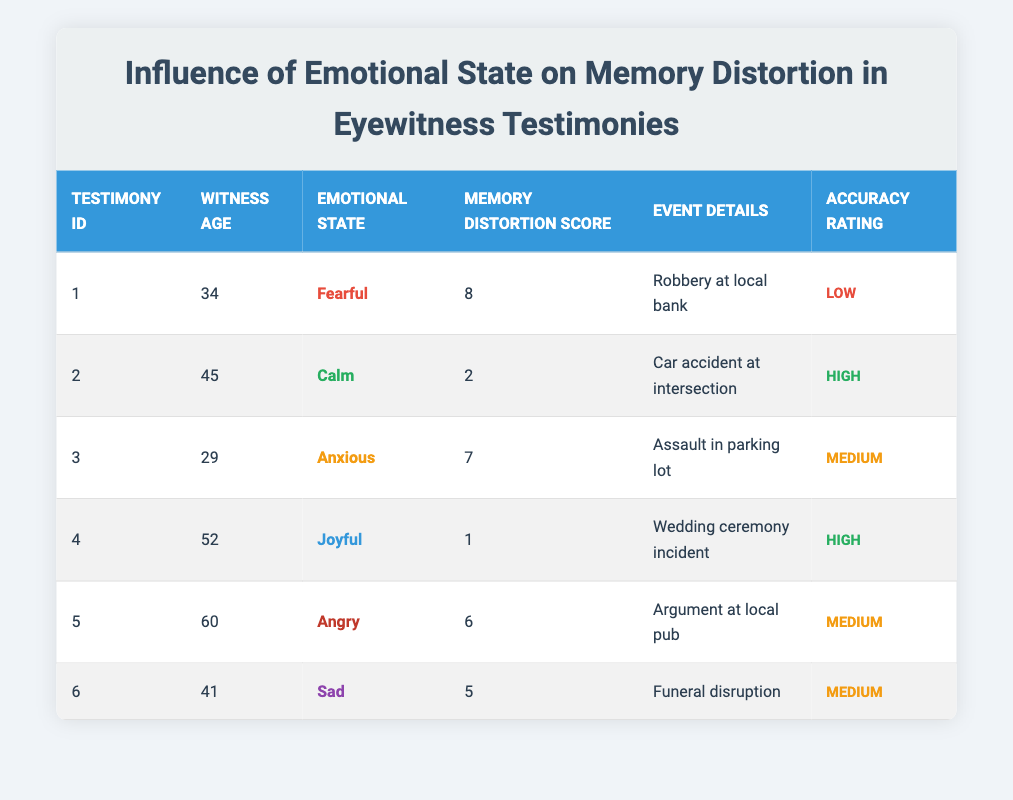What is the Memory Distortion Score for the witness aged 34? From the table, the witness aged 34 is connected to Testimony ID 1, which has a Memory Distortion Score of 8.
Answer: 8 What Emotional State corresponds with the highest Memory Distortion Score? The highest Memory Distortion Score is 8 for the witness with Testimony ID 1, whose Emotional State is "Fearful."
Answer: Fearful How many eyewitness testimonies received a "High" Accuracy Rating? The table shows two testimonies with a "High" Accuracy Rating: Testimony ID 2 (Calm) and Testimony ID 4 (Joyful). Therefore, there are 2 testimonies with a "High" accuracy.
Answer: 2 What is the average Memory Distortion Score for witnesses who reported a "Medium" Accuracy Rating? The Memory Distortion Scores for those with a "Medium" Accuracy Rating are 7, 6, and 5 (from Testimonies 3, 5, and 6). The average is (7 + 6 + 5) / 3 = 18 / 3 = 6.
Answer: 6 Does a witness with an "Angry" emotional state have a higher or lower Memory Distortion Score compared to the "Calm" state? The witness with an "Angry" emotional state has a Memory Distortion Score of 6 while the one with a "Calm" emotional state has a score of 2. Since 6 is greater than 2, the "Angry" emotional state has a higher score.
Answer: Higher Which Emotional State is associated with the least Memory Distortion Score? Testimony ID 4, associated with the Emotional State "Joyful", has the least Memory Distortion Score of 1, which is the lowest in the table.
Answer: Joyful How does the average Memory Distortion Score for witnesses aged over 50 compare to those under 50? Witnesses aged over 50 (52, 60) have scores of 1 and 6, with an average of (1 + 6) / 2 = 3.5. Witnesses under 50 (34, 45, 29, 41) have scores of 8, 2, 7, and 5, averaging (8 + 2 + 7 + 5) / 4 = 5.5. Comparing both, 3.5 < 5.5 means those under 50 have a higher average Memory Distortion Score.
Answer: Lower Is there any testimony from an eyewitness who had a joyful emotional state and also had a low Memory Distortion Score? Yes, the testimony from Testimony ID 4 shows a "Joyful" emotional state and a Memory Distortion Score of 1, which is classified as low.
Answer: Yes What is the Memory Distortion Score difference between the fearful witness and the joyful witness? The Memory Distortion Score for the fearful witness (Testimony ID 1) is 8 and for the joyful witness (Testimony ID 4) is 1. The difference is 8 - 1 = 7.
Answer: 7 